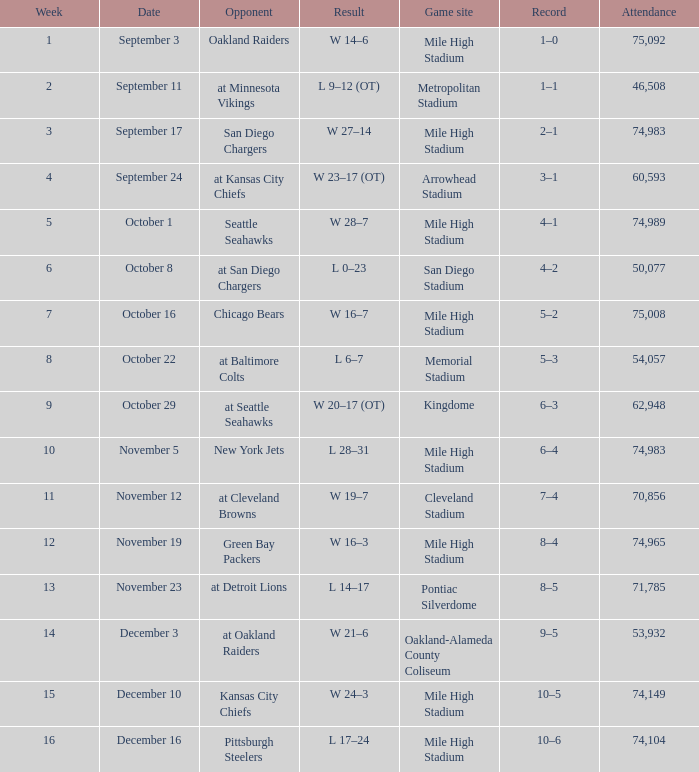Which week has a record of 5–2? 7.0. 